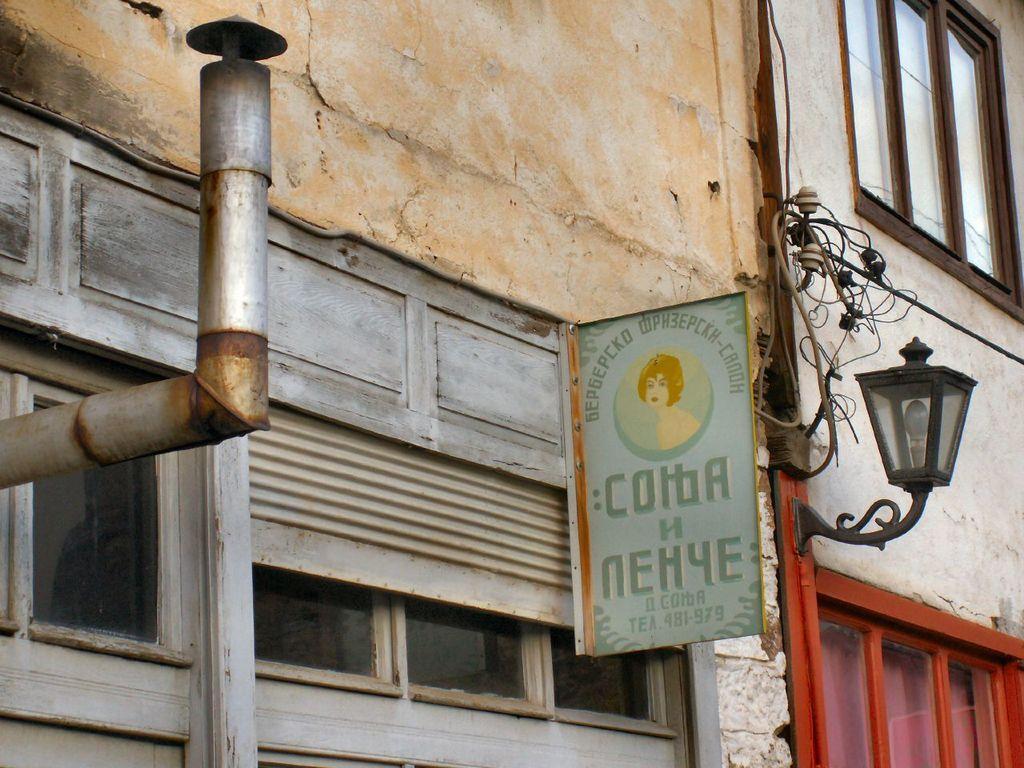Describe this image in one or two sentences. In the image we can see there is a hoarding on the building and there are windows on the wall of the building. 